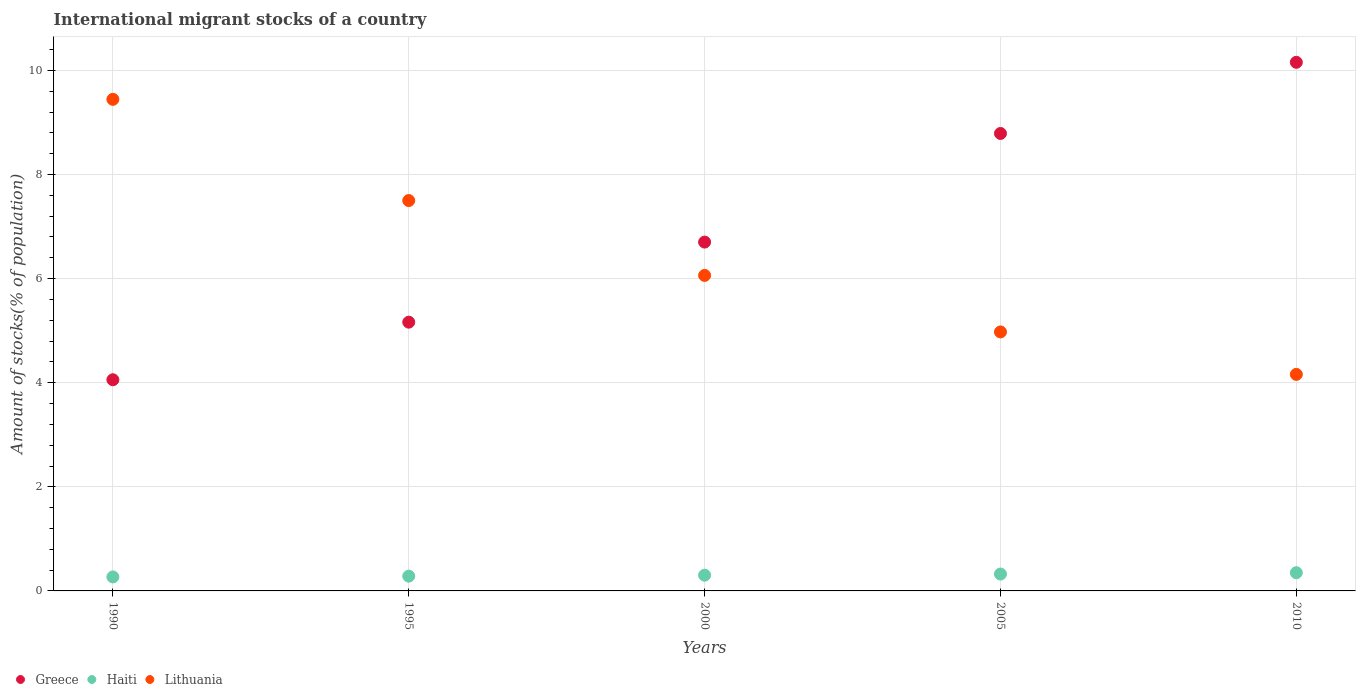Is the number of dotlines equal to the number of legend labels?
Your answer should be very brief. Yes. What is the amount of stocks in in Greece in 1995?
Provide a succinct answer. 5.16. Across all years, what is the maximum amount of stocks in in Lithuania?
Your answer should be compact. 9.44. Across all years, what is the minimum amount of stocks in in Greece?
Ensure brevity in your answer.  4.06. In which year was the amount of stocks in in Lithuania minimum?
Offer a terse response. 2010. What is the total amount of stocks in in Lithuania in the graph?
Ensure brevity in your answer.  32.14. What is the difference between the amount of stocks in in Greece in 1995 and that in 2010?
Your response must be concise. -4.99. What is the difference between the amount of stocks in in Greece in 2005 and the amount of stocks in in Lithuania in 2000?
Ensure brevity in your answer.  2.73. What is the average amount of stocks in in Lithuania per year?
Provide a succinct answer. 6.43. In the year 1995, what is the difference between the amount of stocks in in Lithuania and amount of stocks in in Greece?
Your answer should be very brief. 2.34. In how many years, is the amount of stocks in in Lithuania greater than 5.2 %?
Provide a short and direct response. 3. What is the ratio of the amount of stocks in in Haiti in 1990 to that in 2000?
Make the answer very short. 0.89. Is the difference between the amount of stocks in in Lithuania in 1995 and 2010 greater than the difference between the amount of stocks in in Greece in 1995 and 2010?
Give a very brief answer. Yes. What is the difference between the highest and the second highest amount of stocks in in Lithuania?
Ensure brevity in your answer.  1.94. What is the difference between the highest and the lowest amount of stocks in in Greece?
Offer a terse response. 6.1. In how many years, is the amount of stocks in in Haiti greater than the average amount of stocks in in Haiti taken over all years?
Ensure brevity in your answer.  2. Is it the case that in every year, the sum of the amount of stocks in in Greece and amount of stocks in in Lithuania  is greater than the amount of stocks in in Haiti?
Your response must be concise. Yes. Does the amount of stocks in in Haiti monotonically increase over the years?
Ensure brevity in your answer.  Yes. What is the difference between two consecutive major ticks on the Y-axis?
Ensure brevity in your answer.  2. Does the graph contain grids?
Keep it short and to the point. Yes. How many legend labels are there?
Keep it short and to the point. 3. How are the legend labels stacked?
Provide a short and direct response. Horizontal. What is the title of the graph?
Make the answer very short. International migrant stocks of a country. What is the label or title of the X-axis?
Keep it short and to the point. Years. What is the label or title of the Y-axis?
Offer a very short reply. Amount of stocks(% of population). What is the Amount of stocks(% of population) of Greece in 1990?
Offer a very short reply. 4.06. What is the Amount of stocks(% of population) in Haiti in 1990?
Provide a succinct answer. 0.27. What is the Amount of stocks(% of population) of Lithuania in 1990?
Keep it short and to the point. 9.44. What is the Amount of stocks(% of population) in Greece in 1995?
Offer a very short reply. 5.16. What is the Amount of stocks(% of population) of Haiti in 1995?
Provide a succinct answer. 0.28. What is the Amount of stocks(% of population) of Lithuania in 1995?
Your response must be concise. 7.5. What is the Amount of stocks(% of population) in Greece in 2000?
Offer a very short reply. 6.7. What is the Amount of stocks(% of population) of Haiti in 2000?
Your answer should be very brief. 0.3. What is the Amount of stocks(% of population) of Lithuania in 2000?
Ensure brevity in your answer.  6.06. What is the Amount of stocks(% of population) of Greece in 2005?
Offer a very short reply. 8.79. What is the Amount of stocks(% of population) in Haiti in 2005?
Give a very brief answer. 0.32. What is the Amount of stocks(% of population) of Lithuania in 2005?
Your response must be concise. 4.98. What is the Amount of stocks(% of population) in Greece in 2010?
Ensure brevity in your answer.  10.16. What is the Amount of stocks(% of population) of Haiti in 2010?
Your response must be concise. 0.35. What is the Amount of stocks(% of population) in Lithuania in 2010?
Offer a terse response. 4.16. Across all years, what is the maximum Amount of stocks(% of population) in Greece?
Your answer should be compact. 10.16. Across all years, what is the maximum Amount of stocks(% of population) of Haiti?
Your answer should be very brief. 0.35. Across all years, what is the maximum Amount of stocks(% of population) in Lithuania?
Provide a succinct answer. 9.44. Across all years, what is the minimum Amount of stocks(% of population) in Greece?
Give a very brief answer. 4.06. Across all years, what is the minimum Amount of stocks(% of population) of Haiti?
Your response must be concise. 0.27. Across all years, what is the minimum Amount of stocks(% of population) of Lithuania?
Offer a terse response. 4.16. What is the total Amount of stocks(% of population) in Greece in the graph?
Keep it short and to the point. 34.87. What is the total Amount of stocks(% of population) in Haiti in the graph?
Provide a short and direct response. 1.53. What is the total Amount of stocks(% of population) of Lithuania in the graph?
Give a very brief answer. 32.14. What is the difference between the Amount of stocks(% of population) in Greece in 1990 and that in 1995?
Your answer should be compact. -1.11. What is the difference between the Amount of stocks(% of population) in Haiti in 1990 and that in 1995?
Provide a succinct answer. -0.02. What is the difference between the Amount of stocks(% of population) in Lithuania in 1990 and that in 1995?
Provide a short and direct response. 1.94. What is the difference between the Amount of stocks(% of population) of Greece in 1990 and that in 2000?
Offer a very short reply. -2.64. What is the difference between the Amount of stocks(% of population) in Haiti in 1990 and that in 2000?
Your answer should be compact. -0.03. What is the difference between the Amount of stocks(% of population) of Lithuania in 1990 and that in 2000?
Make the answer very short. 3.38. What is the difference between the Amount of stocks(% of population) of Greece in 1990 and that in 2005?
Your answer should be very brief. -4.73. What is the difference between the Amount of stocks(% of population) in Haiti in 1990 and that in 2005?
Your answer should be very brief. -0.06. What is the difference between the Amount of stocks(% of population) in Lithuania in 1990 and that in 2005?
Keep it short and to the point. 4.47. What is the difference between the Amount of stocks(% of population) in Greece in 1990 and that in 2010?
Your answer should be compact. -6.1. What is the difference between the Amount of stocks(% of population) in Haiti in 1990 and that in 2010?
Your answer should be compact. -0.08. What is the difference between the Amount of stocks(% of population) of Lithuania in 1990 and that in 2010?
Offer a very short reply. 5.28. What is the difference between the Amount of stocks(% of population) in Greece in 1995 and that in 2000?
Offer a very short reply. -1.54. What is the difference between the Amount of stocks(% of population) in Haiti in 1995 and that in 2000?
Ensure brevity in your answer.  -0.02. What is the difference between the Amount of stocks(% of population) of Lithuania in 1995 and that in 2000?
Make the answer very short. 1.44. What is the difference between the Amount of stocks(% of population) of Greece in 1995 and that in 2005?
Your answer should be compact. -3.63. What is the difference between the Amount of stocks(% of population) in Haiti in 1995 and that in 2005?
Provide a short and direct response. -0.04. What is the difference between the Amount of stocks(% of population) of Lithuania in 1995 and that in 2005?
Make the answer very short. 2.52. What is the difference between the Amount of stocks(% of population) in Greece in 1995 and that in 2010?
Provide a succinct answer. -4.99. What is the difference between the Amount of stocks(% of population) in Haiti in 1995 and that in 2010?
Keep it short and to the point. -0.07. What is the difference between the Amount of stocks(% of population) in Lithuania in 1995 and that in 2010?
Ensure brevity in your answer.  3.34. What is the difference between the Amount of stocks(% of population) of Greece in 2000 and that in 2005?
Keep it short and to the point. -2.09. What is the difference between the Amount of stocks(% of population) in Haiti in 2000 and that in 2005?
Your answer should be compact. -0.02. What is the difference between the Amount of stocks(% of population) in Lithuania in 2000 and that in 2005?
Give a very brief answer. 1.09. What is the difference between the Amount of stocks(% of population) in Greece in 2000 and that in 2010?
Provide a short and direct response. -3.45. What is the difference between the Amount of stocks(% of population) of Haiti in 2000 and that in 2010?
Offer a terse response. -0.05. What is the difference between the Amount of stocks(% of population) in Lithuania in 2000 and that in 2010?
Provide a short and direct response. 1.9. What is the difference between the Amount of stocks(% of population) in Greece in 2005 and that in 2010?
Your response must be concise. -1.37. What is the difference between the Amount of stocks(% of population) of Haiti in 2005 and that in 2010?
Your answer should be very brief. -0.03. What is the difference between the Amount of stocks(% of population) of Lithuania in 2005 and that in 2010?
Your response must be concise. 0.82. What is the difference between the Amount of stocks(% of population) in Greece in 1990 and the Amount of stocks(% of population) in Haiti in 1995?
Offer a very short reply. 3.77. What is the difference between the Amount of stocks(% of population) of Greece in 1990 and the Amount of stocks(% of population) of Lithuania in 1995?
Your response must be concise. -3.44. What is the difference between the Amount of stocks(% of population) of Haiti in 1990 and the Amount of stocks(% of population) of Lithuania in 1995?
Give a very brief answer. -7.23. What is the difference between the Amount of stocks(% of population) in Greece in 1990 and the Amount of stocks(% of population) in Haiti in 2000?
Provide a short and direct response. 3.76. What is the difference between the Amount of stocks(% of population) of Greece in 1990 and the Amount of stocks(% of population) of Lithuania in 2000?
Your answer should be very brief. -2. What is the difference between the Amount of stocks(% of population) in Haiti in 1990 and the Amount of stocks(% of population) in Lithuania in 2000?
Keep it short and to the point. -5.79. What is the difference between the Amount of stocks(% of population) of Greece in 1990 and the Amount of stocks(% of population) of Haiti in 2005?
Make the answer very short. 3.73. What is the difference between the Amount of stocks(% of population) of Greece in 1990 and the Amount of stocks(% of population) of Lithuania in 2005?
Provide a succinct answer. -0.92. What is the difference between the Amount of stocks(% of population) in Haiti in 1990 and the Amount of stocks(% of population) in Lithuania in 2005?
Offer a very short reply. -4.71. What is the difference between the Amount of stocks(% of population) in Greece in 1990 and the Amount of stocks(% of population) in Haiti in 2010?
Make the answer very short. 3.71. What is the difference between the Amount of stocks(% of population) of Greece in 1990 and the Amount of stocks(% of population) of Lithuania in 2010?
Give a very brief answer. -0.1. What is the difference between the Amount of stocks(% of population) of Haiti in 1990 and the Amount of stocks(% of population) of Lithuania in 2010?
Your response must be concise. -3.89. What is the difference between the Amount of stocks(% of population) in Greece in 1995 and the Amount of stocks(% of population) in Haiti in 2000?
Ensure brevity in your answer.  4.86. What is the difference between the Amount of stocks(% of population) in Greece in 1995 and the Amount of stocks(% of population) in Lithuania in 2000?
Provide a short and direct response. -0.9. What is the difference between the Amount of stocks(% of population) in Haiti in 1995 and the Amount of stocks(% of population) in Lithuania in 2000?
Ensure brevity in your answer.  -5.78. What is the difference between the Amount of stocks(% of population) of Greece in 1995 and the Amount of stocks(% of population) of Haiti in 2005?
Ensure brevity in your answer.  4.84. What is the difference between the Amount of stocks(% of population) of Greece in 1995 and the Amount of stocks(% of population) of Lithuania in 2005?
Offer a terse response. 0.19. What is the difference between the Amount of stocks(% of population) of Haiti in 1995 and the Amount of stocks(% of population) of Lithuania in 2005?
Offer a very short reply. -4.69. What is the difference between the Amount of stocks(% of population) of Greece in 1995 and the Amount of stocks(% of population) of Haiti in 2010?
Your response must be concise. 4.81. What is the difference between the Amount of stocks(% of population) in Greece in 1995 and the Amount of stocks(% of population) in Lithuania in 2010?
Your answer should be compact. 1. What is the difference between the Amount of stocks(% of population) of Haiti in 1995 and the Amount of stocks(% of population) of Lithuania in 2010?
Make the answer very short. -3.88. What is the difference between the Amount of stocks(% of population) in Greece in 2000 and the Amount of stocks(% of population) in Haiti in 2005?
Provide a short and direct response. 6.38. What is the difference between the Amount of stocks(% of population) in Greece in 2000 and the Amount of stocks(% of population) in Lithuania in 2005?
Your answer should be compact. 1.73. What is the difference between the Amount of stocks(% of population) in Haiti in 2000 and the Amount of stocks(% of population) in Lithuania in 2005?
Give a very brief answer. -4.67. What is the difference between the Amount of stocks(% of population) of Greece in 2000 and the Amount of stocks(% of population) of Haiti in 2010?
Make the answer very short. 6.35. What is the difference between the Amount of stocks(% of population) of Greece in 2000 and the Amount of stocks(% of population) of Lithuania in 2010?
Give a very brief answer. 2.54. What is the difference between the Amount of stocks(% of population) in Haiti in 2000 and the Amount of stocks(% of population) in Lithuania in 2010?
Give a very brief answer. -3.86. What is the difference between the Amount of stocks(% of population) in Greece in 2005 and the Amount of stocks(% of population) in Haiti in 2010?
Your answer should be very brief. 8.44. What is the difference between the Amount of stocks(% of population) of Greece in 2005 and the Amount of stocks(% of population) of Lithuania in 2010?
Your response must be concise. 4.63. What is the difference between the Amount of stocks(% of population) in Haiti in 2005 and the Amount of stocks(% of population) in Lithuania in 2010?
Offer a very short reply. -3.84. What is the average Amount of stocks(% of population) of Greece per year?
Your answer should be compact. 6.97. What is the average Amount of stocks(% of population) of Haiti per year?
Give a very brief answer. 0.31. What is the average Amount of stocks(% of population) in Lithuania per year?
Provide a short and direct response. 6.43. In the year 1990, what is the difference between the Amount of stocks(% of population) of Greece and Amount of stocks(% of population) of Haiti?
Offer a very short reply. 3.79. In the year 1990, what is the difference between the Amount of stocks(% of population) of Greece and Amount of stocks(% of population) of Lithuania?
Provide a short and direct response. -5.39. In the year 1990, what is the difference between the Amount of stocks(% of population) in Haiti and Amount of stocks(% of population) in Lithuania?
Provide a short and direct response. -9.18. In the year 1995, what is the difference between the Amount of stocks(% of population) in Greece and Amount of stocks(% of population) in Haiti?
Your response must be concise. 4.88. In the year 1995, what is the difference between the Amount of stocks(% of population) in Greece and Amount of stocks(% of population) in Lithuania?
Ensure brevity in your answer.  -2.34. In the year 1995, what is the difference between the Amount of stocks(% of population) of Haiti and Amount of stocks(% of population) of Lithuania?
Offer a very short reply. -7.22. In the year 2000, what is the difference between the Amount of stocks(% of population) of Greece and Amount of stocks(% of population) of Haiti?
Keep it short and to the point. 6.4. In the year 2000, what is the difference between the Amount of stocks(% of population) in Greece and Amount of stocks(% of population) in Lithuania?
Give a very brief answer. 0.64. In the year 2000, what is the difference between the Amount of stocks(% of population) of Haiti and Amount of stocks(% of population) of Lithuania?
Your answer should be compact. -5.76. In the year 2005, what is the difference between the Amount of stocks(% of population) of Greece and Amount of stocks(% of population) of Haiti?
Offer a terse response. 8.46. In the year 2005, what is the difference between the Amount of stocks(% of population) in Greece and Amount of stocks(% of population) in Lithuania?
Your response must be concise. 3.81. In the year 2005, what is the difference between the Amount of stocks(% of population) of Haiti and Amount of stocks(% of population) of Lithuania?
Offer a terse response. -4.65. In the year 2010, what is the difference between the Amount of stocks(% of population) of Greece and Amount of stocks(% of population) of Haiti?
Your response must be concise. 9.81. In the year 2010, what is the difference between the Amount of stocks(% of population) in Greece and Amount of stocks(% of population) in Lithuania?
Your response must be concise. 6. In the year 2010, what is the difference between the Amount of stocks(% of population) in Haiti and Amount of stocks(% of population) in Lithuania?
Your response must be concise. -3.81. What is the ratio of the Amount of stocks(% of population) in Greece in 1990 to that in 1995?
Give a very brief answer. 0.79. What is the ratio of the Amount of stocks(% of population) of Haiti in 1990 to that in 1995?
Offer a very short reply. 0.95. What is the ratio of the Amount of stocks(% of population) in Lithuania in 1990 to that in 1995?
Give a very brief answer. 1.26. What is the ratio of the Amount of stocks(% of population) in Greece in 1990 to that in 2000?
Provide a short and direct response. 0.61. What is the ratio of the Amount of stocks(% of population) of Haiti in 1990 to that in 2000?
Your response must be concise. 0.89. What is the ratio of the Amount of stocks(% of population) in Lithuania in 1990 to that in 2000?
Your response must be concise. 1.56. What is the ratio of the Amount of stocks(% of population) of Greece in 1990 to that in 2005?
Your answer should be compact. 0.46. What is the ratio of the Amount of stocks(% of population) in Haiti in 1990 to that in 2005?
Offer a very short reply. 0.83. What is the ratio of the Amount of stocks(% of population) of Lithuania in 1990 to that in 2005?
Make the answer very short. 1.9. What is the ratio of the Amount of stocks(% of population) in Greece in 1990 to that in 2010?
Make the answer very short. 0.4. What is the ratio of the Amount of stocks(% of population) in Haiti in 1990 to that in 2010?
Your response must be concise. 0.77. What is the ratio of the Amount of stocks(% of population) in Lithuania in 1990 to that in 2010?
Your answer should be compact. 2.27. What is the ratio of the Amount of stocks(% of population) in Greece in 1995 to that in 2000?
Your answer should be compact. 0.77. What is the ratio of the Amount of stocks(% of population) of Haiti in 1995 to that in 2000?
Make the answer very short. 0.94. What is the ratio of the Amount of stocks(% of population) in Lithuania in 1995 to that in 2000?
Give a very brief answer. 1.24. What is the ratio of the Amount of stocks(% of population) in Greece in 1995 to that in 2005?
Provide a short and direct response. 0.59. What is the ratio of the Amount of stocks(% of population) in Haiti in 1995 to that in 2005?
Provide a succinct answer. 0.88. What is the ratio of the Amount of stocks(% of population) in Lithuania in 1995 to that in 2005?
Keep it short and to the point. 1.51. What is the ratio of the Amount of stocks(% of population) in Greece in 1995 to that in 2010?
Your answer should be very brief. 0.51. What is the ratio of the Amount of stocks(% of population) of Haiti in 1995 to that in 2010?
Your answer should be compact. 0.81. What is the ratio of the Amount of stocks(% of population) in Lithuania in 1995 to that in 2010?
Ensure brevity in your answer.  1.8. What is the ratio of the Amount of stocks(% of population) in Greece in 2000 to that in 2005?
Offer a terse response. 0.76. What is the ratio of the Amount of stocks(% of population) in Haiti in 2000 to that in 2005?
Your answer should be compact. 0.93. What is the ratio of the Amount of stocks(% of population) in Lithuania in 2000 to that in 2005?
Keep it short and to the point. 1.22. What is the ratio of the Amount of stocks(% of population) of Greece in 2000 to that in 2010?
Ensure brevity in your answer.  0.66. What is the ratio of the Amount of stocks(% of population) in Haiti in 2000 to that in 2010?
Give a very brief answer. 0.86. What is the ratio of the Amount of stocks(% of population) of Lithuania in 2000 to that in 2010?
Ensure brevity in your answer.  1.46. What is the ratio of the Amount of stocks(% of population) in Greece in 2005 to that in 2010?
Offer a very short reply. 0.87. What is the ratio of the Amount of stocks(% of population) of Haiti in 2005 to that in 2010?
Make the answer very short. 0.93. What is the ratio of the Amount of stocks(% of population) of Lithuania in 2005 to that in 2010?
Ensure brevity in your answer.  1.2. What is the difference between the highest and the second highest Amount of stocks(% of population) in Greece?
Your answer should be compact. 1.37. What is the difference between the highest and the second highest Amount of stocks(% of population) of Haiti?
Give a very brief answer. 0.03. What is the difference between the highest and the second highest Amount of stocks(% of population) in Lithuania?
Offer a terse response. 1.94. What is the difference between the highest and the lowest Amount of stocks(% of population) of Greece?
Give a very brief answer. 6.1. What is the difference between the highest and the lowest Amount of stocks(% of population) in Haiti?
Keep it short and to the point. 0.08. What is the difference between the highest and the lowest Amount of stocks(% of population) of Lithuania?
Keep it short and to the point. 5.28. 